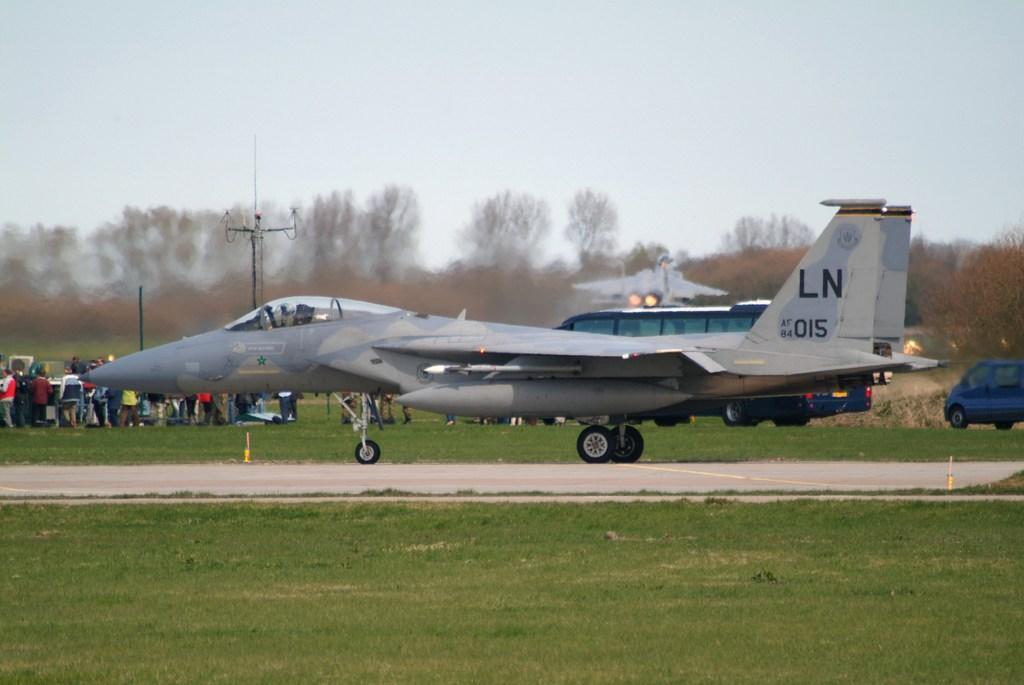<image>
Give a short and clear explanation of the subsequent image. gray fighter jet with LN af 84 015 on tail 